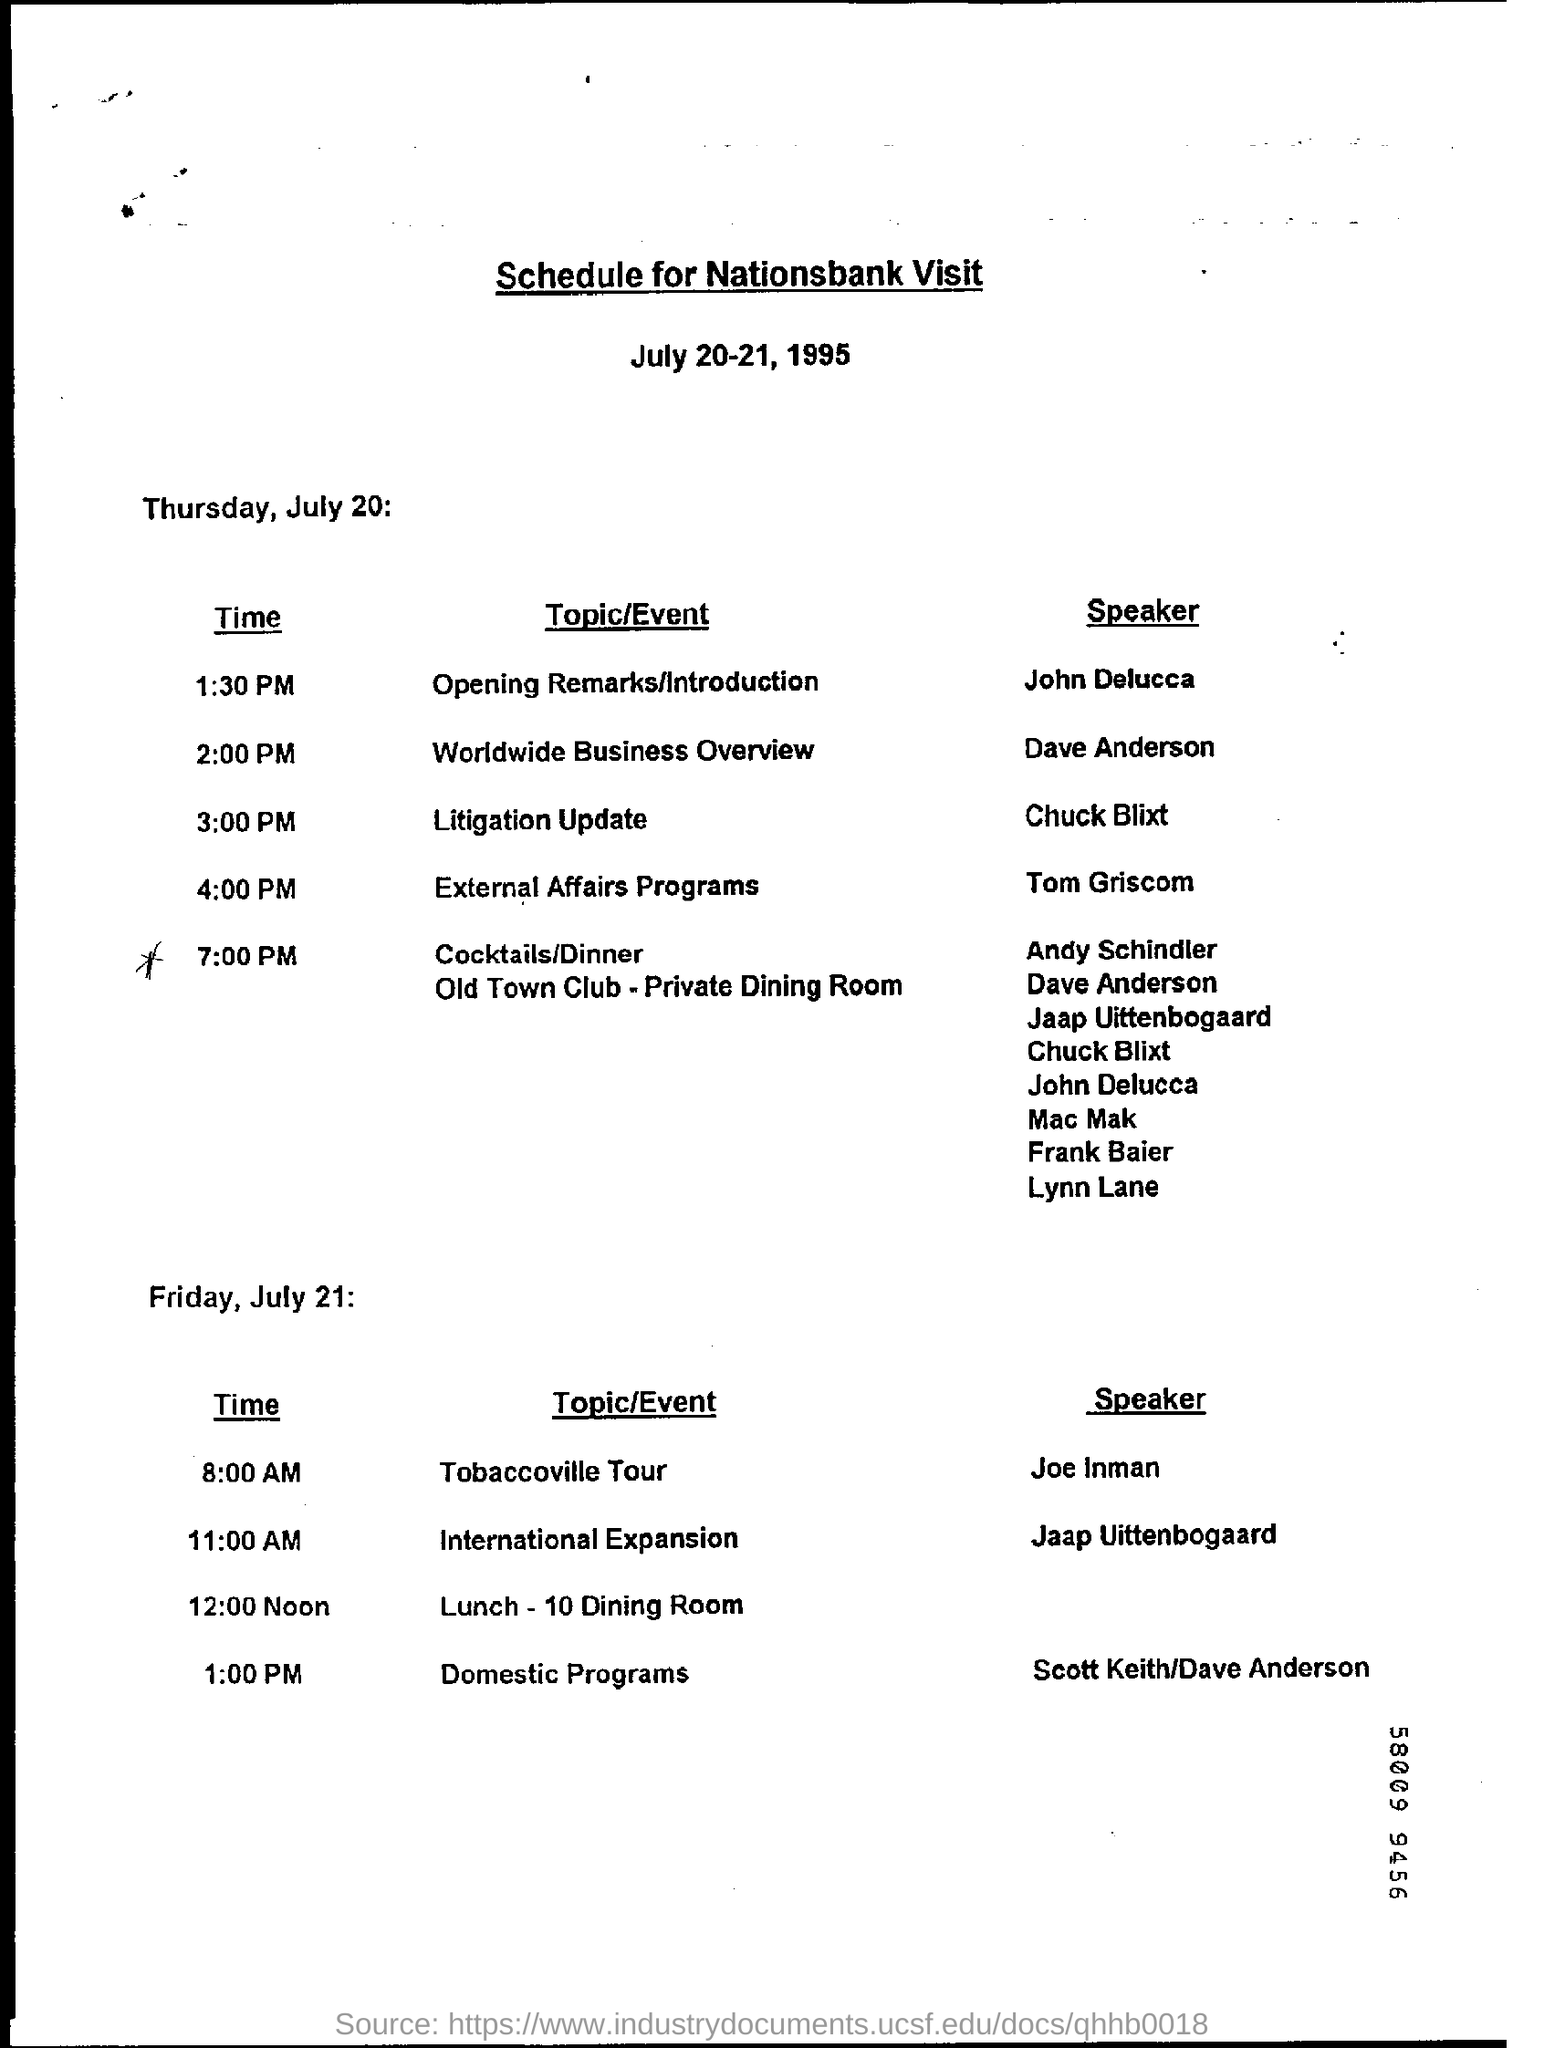Which topic is handled at 1:30 PM?
Your answer should be compact. Opening Remarks/Introduction. Who is the speaker of the topic Litigation Update?
Offer a terse response. Chuck Blixt. When is the dinner scheduled?
Provide a short and direct response. 7:00 PM. Who is the speaker of Tobaccoville Tour?
Your answer should be compact. Joe Inman. 